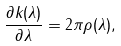Convert formula to latex. <formula><loc_0><loc_0><loc_500><loc_500>\frac { \partial k ( \lambda ) } { \partial \lambda } = 2 \pi \rho ( \lambda ) ,</formula> 